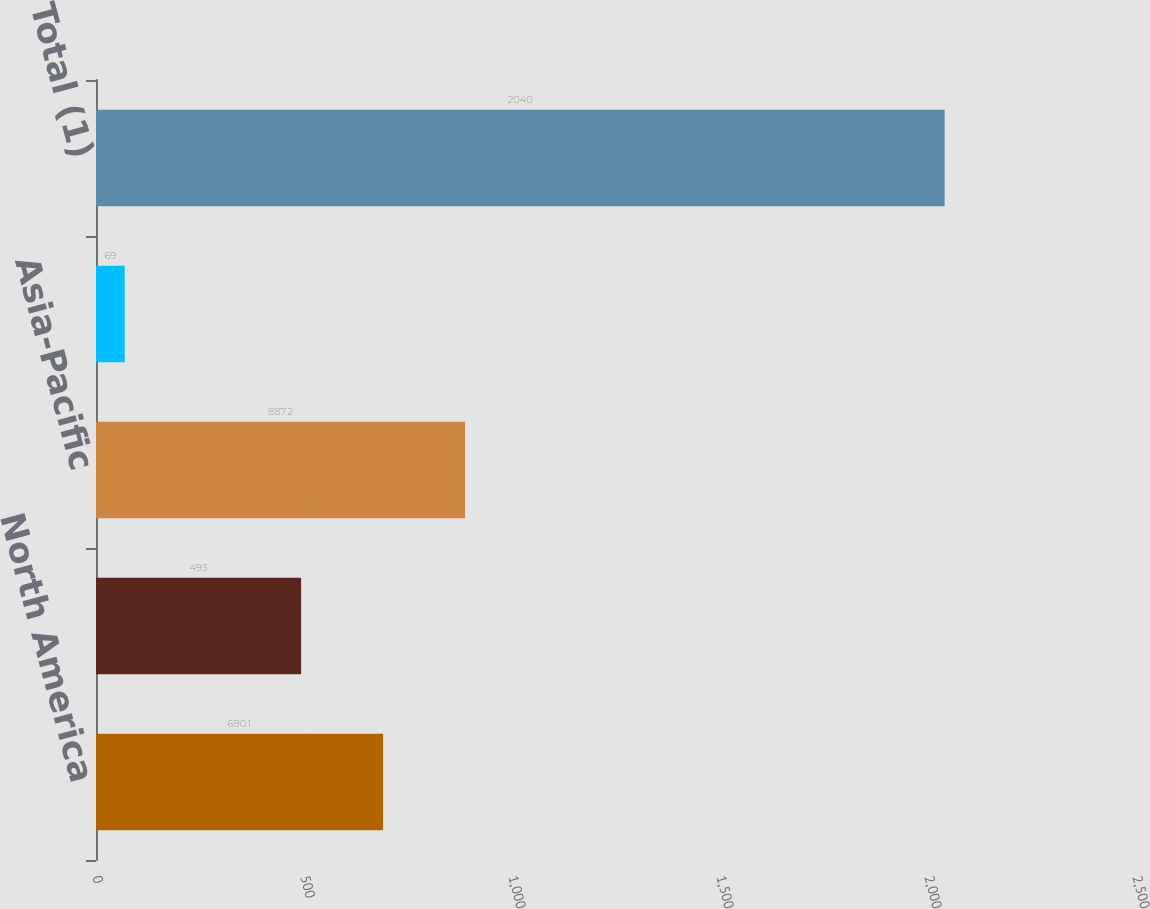Convert chart to OTSL. <chart><loc_0><loc_0><loc_500><loc_500><bar_chart><fcel>North America<fcel>Europe and Africa<fcel>Asia-Pacific<fcel>South America<fcel>Total (1)<nl><fcel>690.1<fcel>493<fcel>887.2<fcel>69<fcel>2040<nl></chart> 